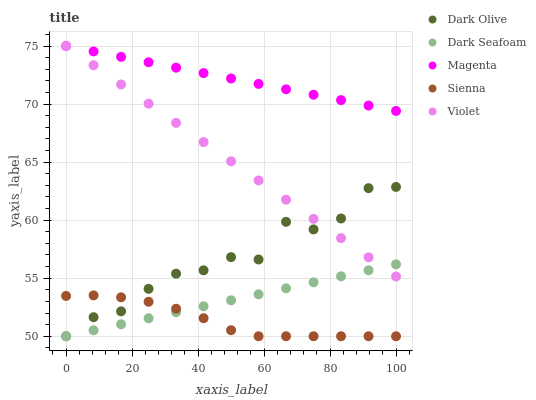Does Sienna have the minimum area under the curve?
Answer yes or no. Yes. Does Magenta have the maximum area under the curve?
Answer yes or no. Yes. Does Dark Seafoam have the minimum area under the curve?
Answer yes or no. No. Does Dark Seafoam have the maximum area under the curve?
Answer yes or no. No. Is Dark Seafoam the smoothest?
Answer yes or no. Yes. Is Dark Olive the roughest?
Answer yes or no. Yes. Is Dark Olive the smoothest?
Answer yes or no. No. Is Dark Seafoam the roughest?
Answer yes or no. No. Does Sienna have the lowest value?
Answer yes or no. Yes. Does Magenta have the lowest value?
Answer yes or no. No. Does Violet have the highest value?
Answer yes or no. Yes. Does Dark Seafoam have the highest value?
Answer yes or no. No. Is Dark Seafoam less than Magenta?
Answer yes or no. Yes. Is Magenta greater than Dark Olive?
Answer yes or no. Yes. Does Dark Olive intersect Sienna?
Answer yes or no. Yes. Is Dark Olive less than Sienna?
Answer yes or no. No. Is Dark Olive greater than Sienna?
Answer yes or no. No. Does Dark Seafoam intersect Magenta?
Answer yes or no. No. 